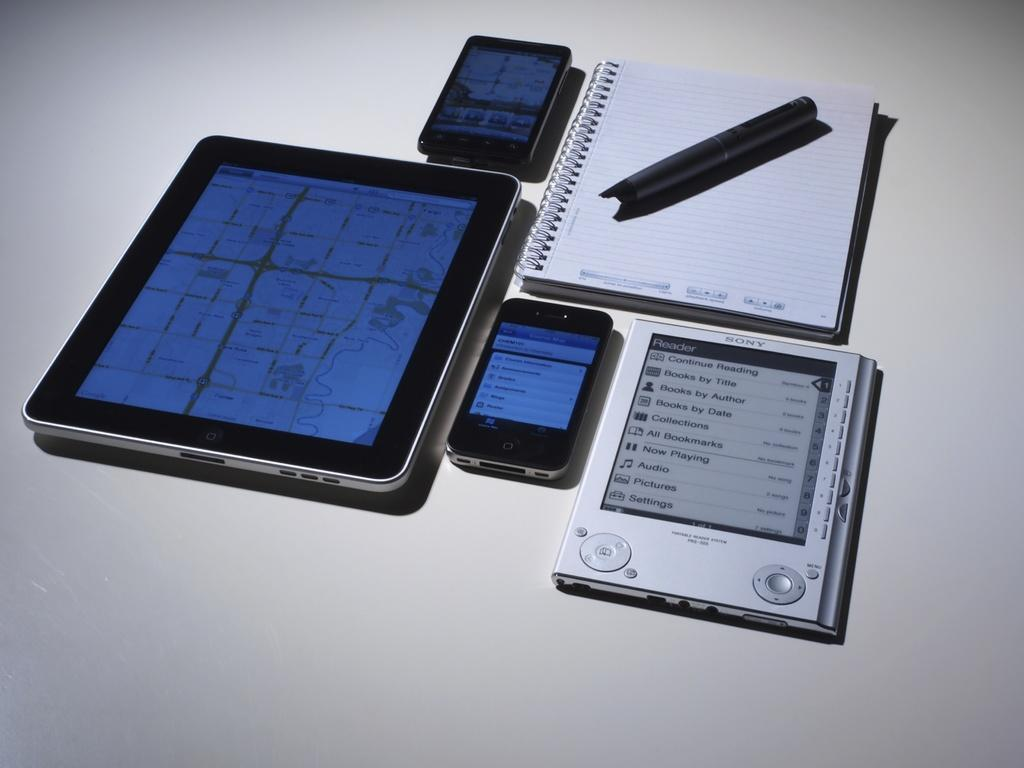How many mobile phones can be seen in the image? There are two mobile phones in the image. What other electronic device is present in the image? There is a tab in the image. What type of reading material is visible in the image? There is a book in the image. Can you describe any other objects present in the image? There are some other objects present in the image, but their specific details are not mentioned in the provided facts. What is the price of the necklace in the image? There is no necklace present in the image, so it is not possible to determine its price. 